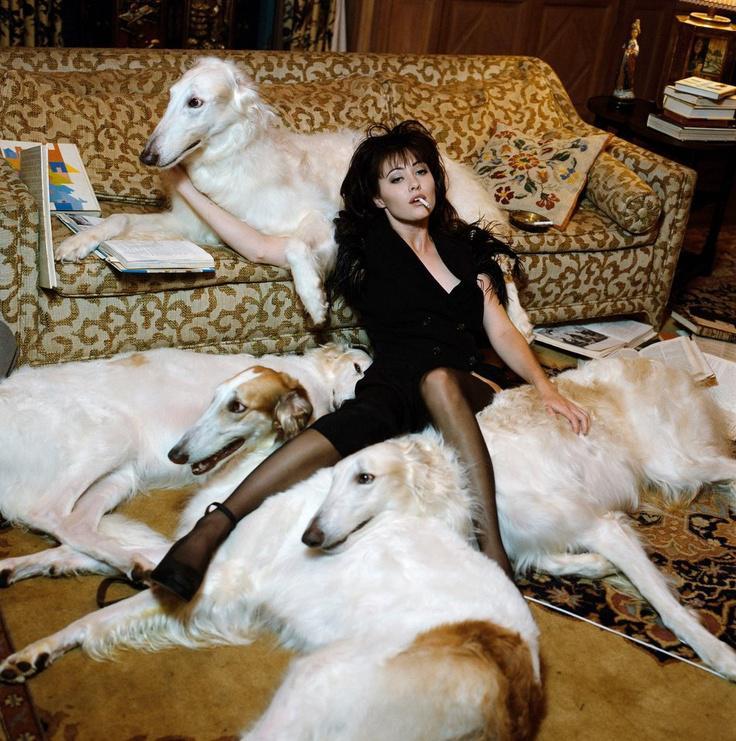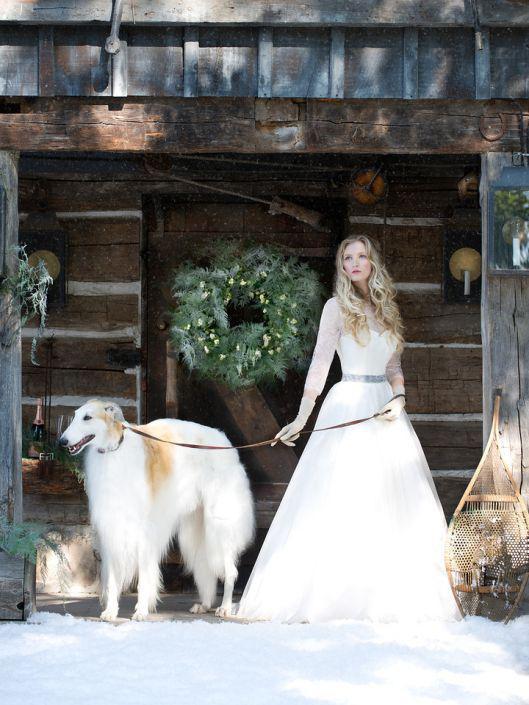The first image is the image on the left, the second image is the image on the right. For the images displayed, is the sentence "A woman is holding a single dog on a leash." factually correct? Answer yes or no. Yes. The first image is the image on the left, the second image is the image on the right. Considering the images on both sides, is "The right image contains exactly two dogs." valid? Answer yes or no. No. 